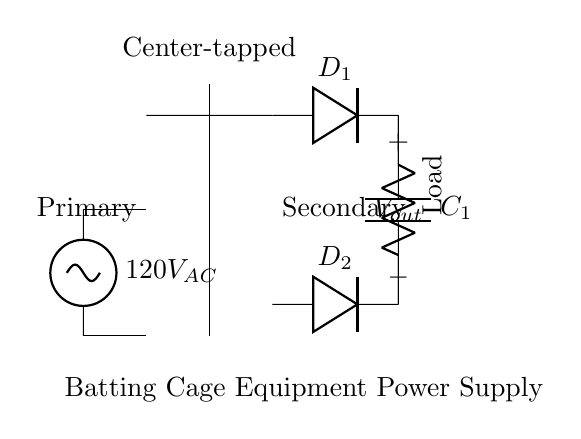What is the voltage of the AC source? The circuit shows a source labeled 120V AC. This indicates that the voltage applied to the primary side of the center-tapped transformer is 120 volts.
Answer: 120V AC What type of transformer is used in this circuit? The circuit diagram specifies a "Center-tapped transformer," which means it has a tap in the center of the secondary winding that divides the voltage into two equal parts.
Answer: Center-tapped How many diodes are in the rectifier? The diagram clearly shows two diodes (labeled D1 and D2) connected to the secondary side of the transformer, each delivering current during different phases of the AC cycle.
Answer: Two What is the purpose of the capacitor in this circuit? The capacitor, labeled C1, is included to smooth out the rectified voltage by filtering out fluctuations and providing a more stable DC output for the load.
Answer: Smoothing What happens to the voltage during rectification? When the AC voltage from the transformer is rectified by the diodes, only the positive halves of the AC wave are allowed to pass, resulting in a pulsating DC voltage before smoothing.
Answer: Pulsating DC What component is labeled as the load? The component labeled as "Load" in the circuit represents the item that consumes power, which in this case, would be the batting cage equipment.
Answer: Load What is the configuration of the diodes in relation to the transformer? The configuration of D1 and D2 in this circuit is in a full-wave bridge arrangement because both diodes are utilized to conduct during the positive and negative half-cycles of the AC input.
Answer: Full-wave 